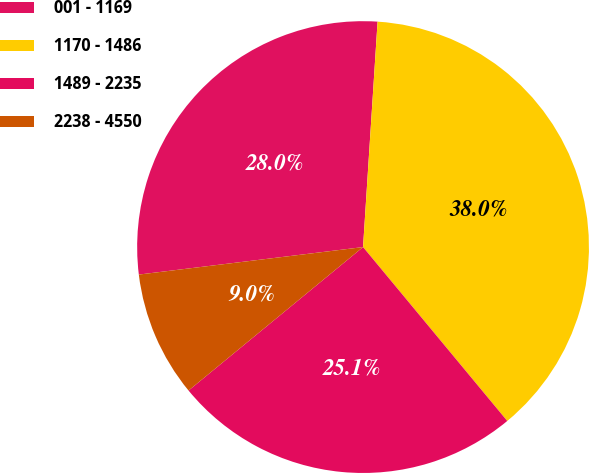Convert chart. <chart><loc_0><loc_0><loc_500><loc_500><pie_chart><fcel>001 - 1169<fcel>1170 - 1486<fcel>1489 - 2235<fcel>2238 - 4550<nl><fcel>27.97%<fcel>37.96%<fcel>25.07%<fcel>9.01%<nl></chart> 